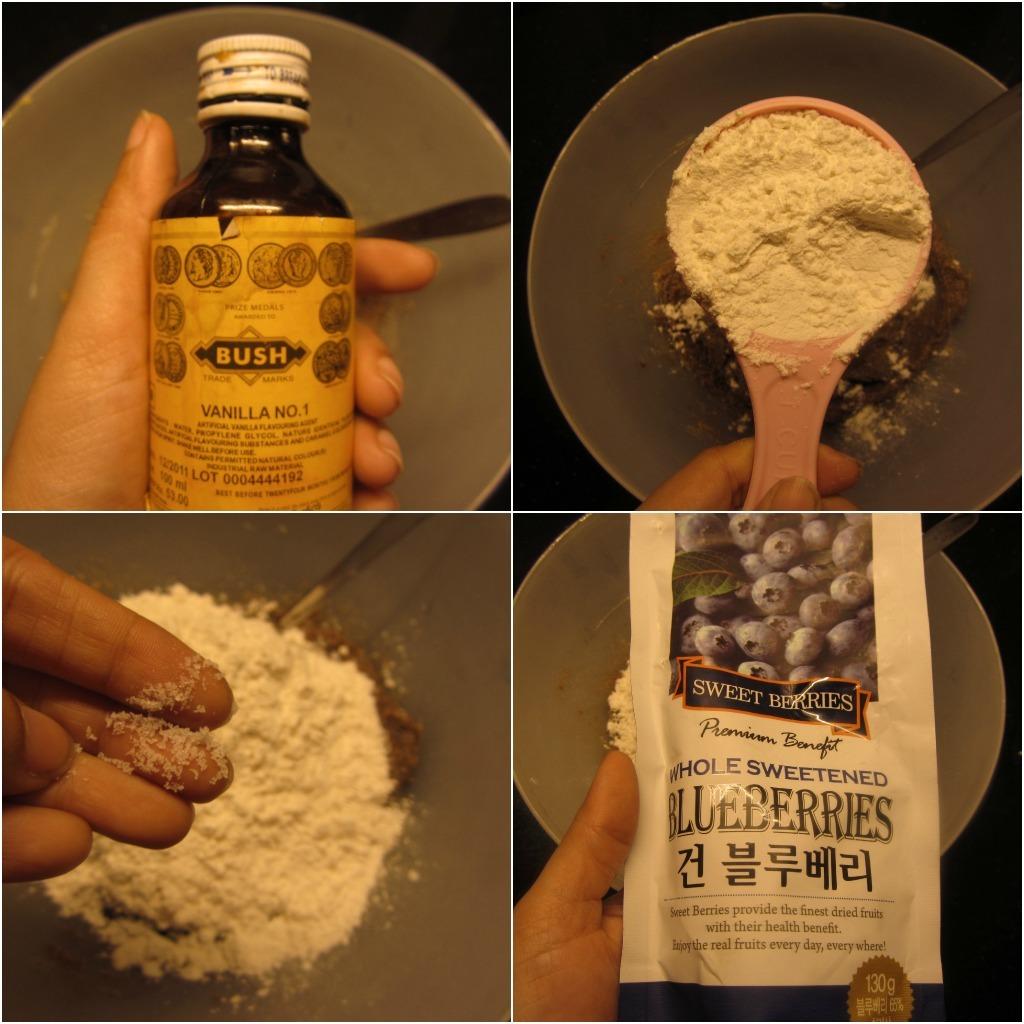What is in the white package?
Provide a succinct answer. Blueberries. Who makes the contents of the bottle?
Give a very brief answer. Bush. 